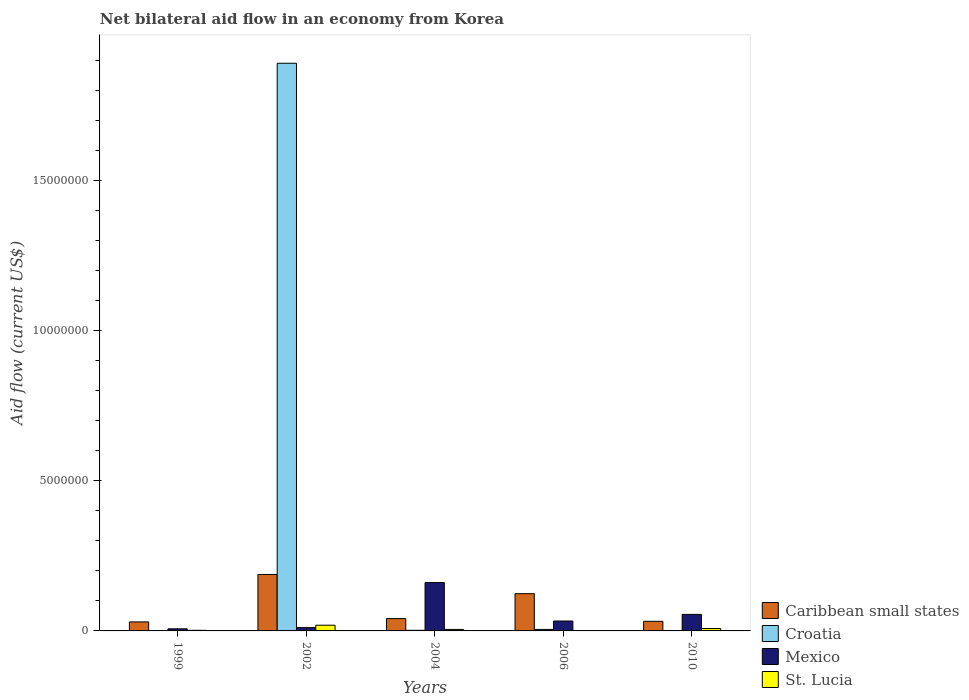How many groups of bars are there?
Provide a succinct answer. 5. How many bars are there on the 3rd tick from the left?
Offer a very short reply. 4. What is the net bilateral aid flow in St. Lucia in 2002?
Your answer should be very brief. 1.90e+05. Across all years, what is the minimum net bilateral aid flow in St. Lucia?
Ensure brevity in your answer.  10000. In which year was the net bilateral aid flow in Croatia maximum?
Keep it short and to the point. 2002. What is the total net bilateral aid flow in Caribbean small states in the graph?
Your response must be concise. 4.15e+06. What is the difference between the net bilateral aid flow in St. Lucia in 1999 and that in 2006?
Your answer should be very brief. 10000. What is the difference between the net bilateral aid flow in St. Lucia in 2010 and the net bilateral aid flow in Croatia in 2002?
Ensure brevity in your answer.  -1.88e+07. What is the average net bilateral aid flow in Mexico per year?
Provide a short and direct response. 5.34e+05. In the year 2004, what is the difference between the net bilateral aid flow in Caribbean small states and net bilateral aid flow in St. Lucia?
Offer a terse response. 3.60e+05. What is the ratio of the net bilateral aid flow in Mexico in 2004 to that in 2006?
Make the answer very short. 4.88. Is the difference between the net bilateral aid flow in Caribbean small states in 2002 and 2010 greater than the difference between the net bilateral aid flow in St. Lucia in 2002 and 2010?
Keep it short and to the point. Yes. What is the difference between the highest and the second highest net bilateral aid flow in Mexico?
Your answer should be compact. 1.06e+06. What is the difference between the highest and the lowest net bilateral aid flow in St. Lucia?
Provide a succinct answer. 1.80e+05. Is the sum of the net bilateral aid flow in Caribbean small states in 2004 and 2010 greater than the maximum net bilateral aid flow in St. Lucia across all years?
Your answer should be compact. Yes. Is it the case that in every year, the sum of the net bilateral aid flow in Caribbean small states and net bilateral aid flow in St. Lucia is greater than the sum of net bilateral aid flow in Croatia and net bilateral aid flow in Mexico?
Provide a short and direct response. Yes. Is it the case that in every year, the sum of the net bilateral aid flow in Croatia and net bilateral aid flow in Caribbean small states is greater than the net bilateral aid flow in St. Lucia?
Provide a short and direct response. Yes. How many bars are there?
Keep it short and to the point. 19. Are all the bars in the graph horizontal?
Offer a terse response. No. How many years are there in the graph?
Keep it short and to the point. 5. Does the graph contain any zero values?
Your answer should be very brief. Yes. Does the graph contain grids?
Ensure brevity in your answer.  No. Where does the legend appear in the graph?
Your answer should be very brief. Bottom right. How are the legend labels stacked?
Provide a succinct answer. Vertical. What is the title of the graph?
Provide a succinct answer. Net bilateral aid flow in an economy from Korea. Does "Mauritius" appear as one of the legend labels in the graph?
Your answer should be very brief. No. What is the label or title of the X-axis?
Keep it short and to the point. Years. What is the label or title of the Y-axis?
Offer a very short reply. Aid flow (current US$). What is the Aid flow (current US$) of Croatia in 1999?
Your answer should be compact. 10000. What is the Aid flow (current US$) of St. Lucia in 1999?
Offer a very short reply. 2.00e+04. What is the Aid flow (current US$) of Caribbean small states in 2002?
Keep it short and to the point. 1.88e+06. What is the Aid flow (current US$) of Croatia in 2002?
Offer a very short reply. 1.89e+07. What is the Aid flow (current US$) of Mexico in 2002?
Make the answer very short. 1.10e+05. What is the Aid flow (current US$) in Croatia in 2004?
Provide a short and direct response. 2.00e+04. What is the Aid flow (current US$) in Mexico in 2004?
Keep it short and to the point. 1.61e+06. What is the Aid flow (current US$) in Caribbean small states in 2006?
Give a very brief answer. 1.24e+06. What is the Aid flow (current US$) in Croatia in 2006?
Your answer should be compact. 5.00e+04. What is the Aid flow (current US$) of Mexico in 2006?
Make the answer very short. 3.30e+05. What is the Aid flow (current US$) in St. Lucia in 2006?
Offer a very short reply. 10000. What is the Aid flow (current US$) in Caribbean small states in 2010?
Make the answer very short. 3.20e+05. What is the Aid flow (current US$) in Mexico in 2010?
Offer a very short reply. 5.50e+05. What is the Aid flow (current US$) of St. Lucia in 2010?
Your answer should be very brief. 8.00e+04. Across all years, what is the maximum Aid flow (current US$) of Caribbean small states?
Your answer should be compact. 1.88e+06. Across all years, what is the maximum Aid flow (current US$) of Croatia?
Your response must be concise. 1.89e+07. Across all years, what is the maximum Aid flow (current US$) in Mexico?
Give a very brief answer. 1.61e+06. Across all years, what is the minimum Aid flow (current US$) in Croatia?
Offer a very short reply. 0. What is the total Aid flow (current US$) in Caribbean small states in the graph?
Provide a succinct answer. 4.15e+06. What is the total Aid flow (current US$) of Croatia in the graph?
Your response must be concise. 1.90e+07. What is the total Aid flow (current US$) of Mexico in the graph?
Provide a short and direct response. 2.67e+06. What is the difference between the Aid flow (current US$) in Caribbean small states in 1999 and that in 2002?
Your answer should be very brief. -1.58e+06. What is the difference between the Aid flow (current US$) of Croatia in 1999 and that in 2002?
Your response must be concise. -1.89e+07. What is the difference between the Aid flow (current US$) of St. Lucia in 1999 and that in 2002?
Give a very brief answer. -1.70e+05. What is the difference between the Aid flow (current US$) in Croatia in 1999 and that in 2004?
Provide a succinct answer. -10000. What is the difference between the Aid flow (current US$) of Mexico in 1999 and that in 2004?
Your answer should be compact. -1.54e+06. What is the difference between the Aid flow (current US$) of Caribbean small states in 1999 and that in 2006?
Offer a terse response. -9.40e+05. What is the difference between the Aid flow (current US$) in Mexico in 1999 and that in 2010?
Your answer should be very brief. -4.80e+05. What is the difference between the Aid flow (current US$) of St. Lucia in 1999 and that in 2010?
Keep it short and to the point. -6.00e+04. What is the difference between the Aid flow (current US$) in Caribbean small states in 2002 and that in 2004?
Your answer should be compact. 1.47e+06. What is the difference between the Aid flow (current US$) in Croatia in 2002 and that in 2004?
Offer a terse response. 1.89e+07. What is the difference between the Aid flow (current US$) in Mexico in 2002 and that in 2004?
Ensure brevity in your answer.  -1.50e+06. What is the difference between the Aid flow (current US$) of Caribbean small states in 2002 and that in 2006?
Your response must be concise. 6.40e+05. What is the difference between the Aid flow (current US$) of Croatia in 2002 and that in 2006?
Provide a short and direct response. 1.88e+07. What is the difference between the Aid flow (current US$) in Mexico in 2002 and that in 2006?
Keep it short and to the point. -2.20e+05. What is the difference between the Aid flow (current US$) in St. Lucia in 2002 and that in 2006?
Your answer should be compact. 1.80e+05. What is the difference between the Aid flow (current US$) of Caribbean small states in 2002 and that in 2010?
Offer a terse response. 1.56e+06. What is the difference between the Aid flow (current US$) of Mexico in 2002 and that in 2010?
Give a very brief answer. -4.40e+05. What is the difference between the Aid flow (current US$) in Caribbean small states in 2004 and that in 2006?
Offer a very short reply. -8.30e+05. What is the difference between the Aid flow (current US$) of Croatia in 2004 and that in 2006?
Your response must be concise. -3.00e+04. What is the difference between the Aid flow (current US$) in Mexico in 2004 and that in 2006?
Give a very brief answer. 1.28e+06. What is the difference between the Aid flow (current US$) of Caribbean small states in 2004 and that in 2010?
Ensure brevity in your answer.  9.00e+04. What is the difference between the Aid flow (current US$) of Mexico in 2004 and that in 2010?
Provide a short and direct response. 1.06e+06. What is the difference between the Aid flow (current US$) of St. Lucia in 2004 and that in 2010?
Offer a terse response. -3.00e+04. What is the difference between the Aid flow (current US$) of Caribbean small states in 2006 and that in 2010?
Your answer should be compact. 9.20e+05. What is the difference between the Aid flow (current US$) in St. Lucia in 2006 and that in 2010?
Give a very brief answer. -7.00e+04. What is the difference between the Aid flow (current US$) in Caribbean small states in 1999 and the Aid flow (current US$) in Croatia in 2002?
Offer a very short reply. -1.86e+07. What is the difference between the Aid flow (current US$) in Croatia in 1999 and the Aid flow (current US$) in Mexico in 2002?
Provide a short and direct response. -1.00e+05. What is the difference between the Aid flow (current US$) of Croatia in 1999 and the Aid flow (current US$) of St. Lucia in 2002?
Your response must be concise. -1.80e+05. What is the difference between the Aid flow (current US$) of Mexico in 1999 and the Aid flow (current US$) of St. Lucia in 2002?
Make the answer very short. -1.20e+05. What is the difference between the Aid flow (current US$) in Caribbean small states in 1999 and the Aid flow (current US$) in Mexico in 2004?
Your answer should be compact. -1.31e+06. What is the difference between the Aid flow (current US$) of Caribbean small states in 1999 and the Aid flow (current US$) of St. Lucia in 2004?
Provide a short and direct response. 2.50e+05. What is the difference between the Aid flow (current US$) in Croatia in 1999 and the Aid flow (current US$) in Mexico in 2004?
Offer a terse response. -1.60e+06. What is the difference between the Aid flow (current US$) of Croatia in 1999 and the Aid flow (current US$) of St. Lucia in 2004?
Provide a succinct answer. -4.00e+04. What is the difference between the Aid flow (current US$) of Mexico in 1999 and the Aid flow (current US$) of St. Lucia in 2004?
Offer a very short reply. 2.00e+04. What is the difference between the Aid flow (current US$) of Caribbean small states in 1999 and the Aid flow (current US$) of St. Lucia in 2006?
Provide a succinct answer. 2.90e+05. What is the difference between the Aid flow (current US$) of Croatia in 1999 and the Aid flow (current US$) of Mexico in 2006?
Your response must be concise. -3.20e+05. What is the difference between the Aid flow (current US$) in Croatia in 1999 and the Aid flow (current US$) in St. Lucia in 2006?
Provide a succinct answer. 0. What is the difference between the Aid flow (current US$) in Caribbean small states in 1999 and the Aid flow (current US$) in Mexico in 2010?
Your answer should be very brief. -2.50e+05. What is the difference between the Aid flow (current US$) of Caribbean small states in 1999 and the Aid flow (current US$) of St. Lucia in 2010?
Ensure brevity in your answer.  2.20e+05. What is the difference between the Aid flow (current US$) in Croatia in 1999 and the Aid flow (current US$) in Mexico in 2010?
Your response must be concise. -5.40e+05. What is the difference between the Aid flow (current US$) in Mexico in 1999 and the Aid flow (current US$) in St. Lucia in 2010?
Provide a succinct answer. -10000. What is the difference between the Aid flow (current US$) of Caribbean small states in 2002 and the Aid flow (current US$) of Croatia in 2004?
Ensure brevity in your answer.  1.86e+06. What is the difference between the Aid flow (current US$) of Caribbean small states in 2002 and the Aid flow (current US$) of Mexico in 2004?
Keep it short and to the point. 2.70e+05. What is the difference between the Aid flow (current US$) of Caribbean small states in 2002 and the Aid flow (current US$) of St. Lucia in 2004?
Give a very brief answer. 1.83e+06. What is the difference between the Aid flow (current US$) in Croatia in 2002 and the Aid flow (current US$) in Mexico in 2004?
Your answer should be compact. 1.73e+07. What is the difference between the Aid flow (current US$) in Croatia in 2002 and the Aid flow (current US$) in St. Lucia in 2004?
Offer a terse response. 1.88e+07. What is the difference between the Aid flow (current US$) of Caribbean small states in 2002 and the Aid flow (current US$) of Croatia in 2006?
Offer a terse response. 1.83e+06. What is the difference between the Aid flow (current US$) of Caribbean small states in 2002 and the Aid flow (current US$) of Mexico in 2006?
Give a very brief answer. 1.55e+06. What is the difference between the Aid flow (current US$) in Caribbean small states in 2002 and the Aid flow (current US$) in St. Lucia in 2006?
Your response must be concise. 1.87e+06. What is the difference between the Aid flow (current US$) in Croatia in 2002 and the Aid flow (current US$) in Mexico in 2006?
Your response must be concise. 1.86e+07. What is the difference between the Aid flow (current US$) in Croatia in 2002 and the Aid flow (current US$) in St. Lucia in 2006?
Provide a short and direct response. 1.89e+07. What is the difference between the Aid flow (current US$) of Mexico in 2002 and the Aid flow (current US$) of St. Lucia in 2006?
Provide a short and direct response. 1.00e+05. What is the difference between the Aid flow (current US$) in Caribbean small states in 2002 and the Aid flow (current US$) in Mexico in 2010?
Your answer should be very brief. 1.33e+06. What is the difference between the Aid flow (current US$) in Caribbean small states in 2002 and the Aid flow (current US$) in St. Lucia in 2010?
Keep it short and to the point. 1.80e+06. What is the difference between the Aid flow (current US$) in Croatia in 2002 and the Aid flow (current US$) in Mexico in 2010?
Keep it short and to the point. 1.84e+07. What is the difference between the Aid flow (current US$) of Croatia in 2002 and the Aid flow (current US$) of St. Lucia in 2010?
Make the answer very short. 1.88e+07. What is the difference between the Aid flow (current US$) of Mexico in 2002 and the Aid flow (current US$) of St. Lucia in 2010?
Provide a succinct answer. 3.00e+04. What is the difference between the Aid flow (current US$) of Croatia in 2004 and the Aid flow (current US$) of Mexico in 2006?
Offer a terse response. -3.10e+05. What is the difference between the Aid flow (current US$) of Croatia in 2004 and the Aid flow (current US$) of St. Lucia in 2006?
Your response must be concise. 10000. What is the difference between the Aid flow (current US$) of Mexico in 2004 and the Aid flow (current US$) of St. Lucia in 2006?
Make the answer very short. 1.60e+06. What is the difference between the Aid flow (current US$) in Caribbean small states in 2004 and the Aid flow (current US$) in Mexico in 2010?
Provide a short and direct response. -1.40e+05. What is the difference between the Aid flow (current US$) of Croatia in 2004 and the Aid flow (current US$) of Mexico in 2010?
Offer a very short reply. -5.30e+05. What is the difference between the Aid flow (current US$) in Croatia in 2004 and the Aid flow (current US$) in St. Lucia in 2010?
Offer a terse response. -6.00e+04. What is the difference between the Aid flow (current US$) of Mexico in 2004 and the Aid flow (current US$) of St. Lucia in 2010?
Keep it short and to the point. 1.53e+06. What is the difference between the Aid flow (current US$) in Caribbean small states in 2006 and the Aid flow (current US$) in Mexico in 2010?
Provide a succinct answer. 6.90e+05. What is the difference between the Aid flow (current US$) in Caribbean small states in 2006 and the Aid flow (current US$) in St. Lucia in 2010?
Offer a terse response. 1.16e+06. What is the difference between the Aid flow (current US$) in Croatia in 2006 and the Aid flow (current US$) in Mexico in 2010?
Your response must be concise. -5.00e+05. What is the difference between the Aid flow (current US$) of Croatia in 2006 and the Aid flow (current US$) of St. Lucia in 2010?
Your answer should be very brief. -3.00e+04. What is the difference between the Aid flow (current US$) of Mexico in 2006 and the Aid flow (current US$) of St. Lucia in 2010?
Make the answer very short. 2.50e+05. What is the average Aid flow (current US$) in Caribbean small states per year?
Your answer should be compact. 8.30e+05. What is the average Aid flow (current US$) of Croatia per year?
Make the answer very short. 3.80e+06. What is the average Aid flow (current US$) of Mexico per year?
Provide a short and direct response. 5.34e+05. In the year 1999, what is the difference between the Aid flow (current US$) in Caribbean small states and Aid flow (current US$) in Croatia?
Ensure brevity in your answer.  2.90e+05. In the year 1999, what is the difference between the Aid flow (current US$) in Caribbean small states and Aid flow (current US$) in Mexico?
Your response must be concise. 2.30e+05. In the year 1999, what is the difference between the Aid flow (current US$) in Croatia and Aid flow (current US$) in Mexico?
Give a very brief answer. -6.00e+04. In the year 1999, what is the difference between the Aid flow (current US$) in Croatia and Aid flow (current US$) in St. Lucia?
Ensure brevity in your answer.  -10000. In the year 1999, what is the difference between the Aid flow (current US$) of Mexico and Aid flow (current US$) of St. Lucia?
Your response must be concise. 5.00e+04. In the year 2002, what is the difference between the Aid flow (current US$) in Caribbean small states and Aid flow (current US$) in Croatia?
Ensure brevity in your answer.  -1.70e+07. In the year 2002, what is the difference between the Aid flow (current US$) in Caribbean small states and Aid flow (current US$) in Mexico?
Give a very brief answer. 1.77e+06. In the year 2002, what is the difference between the Aid flow (current US$) in Caribbean small states and Aid flow (current US$) in St. Lucia?
Your answer should be very brief. 1.69e+06. In the year 2002, what is the difference between the Aid flow (current US$) in Croatia and Aid flow (current US$) in Mexico?
Your response must be concise. 1.88e+07. In the year 2002, what is the difference between the Aid flow (current US$) in Croatia and Aid flow (current US$) in St. Lucia?
Your answer should be very brief. 1.87e+07. In the year 2002, what is the difference between the Aid flow (current US$) of Mexico and Aid flow (current US$) of St. Lucia?
Offer a very short reply. -8.00e+04. In the year 2004, what is the difference between the Aid flow (current US$) in Caribbean small states and Aid flow (current US$) in Mexico?
Make the answer very short. -1.20e+06. In the year 2004, what is the difference between the Aid flow (current US$) of Croatia and Aid flow (current US$) of Mexico?
Your answer should be very brief. -1.59e+06. In the year 2004, what is the difference between the Aid flow (current US$) of Mexico and Aid flow (current US$) of St. Lucia?
Offer a terse response. 1.56e+06. In the year 2006, what is the difference between the Aid flow (current US$) in Caribbean small states and Aid flow (current US$) in Croatia?
Make the answer very short. 1.19e+06. In the year 2006, what is the difference between the Aid flow (current US$) of Caribbean small states and Aid flow (current US$) of Mexico?
Provide a short and direct response. 9.10e+05. In the year 2006, what is the difference between the Aid flow (current US$) of Caribbean small states and Aid flow (current US$) of St. Lucia?
Keep it short and to the point. 1.23e+06. In the year 2006, what is the difference between the Aid flow (current US$) in Croatia and Aid flow (current US$) in Mexico?
Offer a terse response. -2.80e+05. In the year 2010, what is the difference between the Aid flow (current US$) of Caribbean small states and Aid flow (current US$) of Mexico?
Your answer should be very brief. -2.30e+05. In the year 2010, what is the difference between the Aid flow (current US$) of Caribbean small states and Aid flow (current US$) of St. Lucia?
Ensure brevity in your answer.  2.40e+05. In the year 2010, what is the difference between the Aid flow (current US$) in Mexico and Aid flow (current US$) in St. Lucia?
Your response must be concise. 4.70e+05. What is the ratio of the Aid flow (current US$) of Caribbean small states in 1999 to that in 2002?
Offer a very short reply. 0.16. What is the ratio of the Aid flow (current US$) of Mexico in 1999 to that in 2002?
Keep it short and to the point. 0.64. What is the ratio of the Aid flow (current US$) of St. Lucia in 1999 to that in 2002?
Offer a very short reply. 0.11. What is the ratio of the Aid flow (current US$) of Caribbean small states in 1999 to that in 2004?
Offer a very short reply. 0.73. What is the ratio of the Aid flow (current US$) in Mexico in 1999 to that in 2004?
Provide a short and direct response. 0.04. What is the ratio of the Aid flow (current US$) of St. Lucia in 1999 to that in 2004?
Ensure brevity in your answer.  0.4. What is the ratio of the Aid flow (current US$) of Caribbean small states in 1999 to that in 2006?
Provide a short and direct response. 0.24. What is the ratio of the Aid flow (current US$) of Croatia in 1999 to that in 2006?
Keep it short and to the point. 0.2. What is the ratio of the Aid flow (current US$) of Mexico in 1999 to that in 2006?
Give a very brief answer. 0.21. What is the ratio of the Aid flow (current US$) of Caribbean small states in 1999 to that in 2010?
Ensure brevity in your answer.  0.94. What is the ratio of the Aid flow (current US$) of Mexico in 1999 to that in 2010?
Keep it short and to the point. 0.13. What is the ratio of the Aid flow (current US$) in Caribbean small states in 2002 to that in 2004?
Provide a short and direct response. 4.59. What is the ratio of the Aid flow (current US$) in Croatia in 2002 to that in 2004?
Make the answer very short. 945. What is the ratio of the Aid flow (current US$) of Mexico in 2002 to that in 2004?
Provide a succinct answer. 0.07. What is the ratio of the Aid flow (current US$) of St. Lucia in 2002 to that in 2004?
Give a very brief answer. 3.8. What is the ratio of the Aid flow (current US$) of Caribbean small states in 2002 to that in 2006?
Make the answer very short. 1.52. What is the ratio of the Aid flow (current US$) in Croatia in 2002 to that in 2006?
Make the answer very short. 378. What is the ratio of the Aid flow (current US$) in St. Lucia in 2002 to that in 2006?
Offer a terse response. 19. What is the ratio of the Aid flow (current US$) in Caribbean small states in 2002 to that in 2010?
Ensure brevity in your answer.  5.88. What is the ratio of the Aid flow (current US$) in St. Lucia in 2002 to that in 2010?
Keep it short and to the point. 2.38. What is the ratio of the Aid flow (current US$) of Caribbean small states in 2004 to that in 2006?
Your answer should be very brief. 0.33. What is the ratio of the Aid flow (current US$) of Mexico in 2004 to that in 2006?
Ensure brevity in your answer.  4.88. What is the ratio of the Aid flow (current US$) of St. Lucia in 2004 to that in 2006?
Your answer should be very brief. 5. What is the ratio of the Aid flow (current US$) of Caribbean small states in 2004 to that in 2010?
Offer a very short reply. 1.28. What is the ratio of the Aid flow (current US$) of Mexico in 2004 to that in 2010?
Ensure brevity in your answer.  2.93. What is the ratio of the Aid flow (current US$) in Caribbean small states in 2006 to that in 2010?
Make the answer very short. 3.88. What is the ratio of the Aid flow (current US$) in Mexico in 2006 to that in 2010?
Make the answer very short. 0.6. What is the difference between the highest and the second highest Aid flow (current US$) of Caribbean small states?
Provide a succinct answer. 6.40e+05. What is the difference between the highest and the second highest Aid flow (current US$) in Croatia?
Provide a succinct answer. 1.88e+07. What is the difference between the highest and the second highest Aid flow (current US$) of Mexico?
Give a very brief answer. 1.06e+06. What is the difference between the highest and the lowest Aid flow (current US$) in Caribbean small states?
Ensure brevity in your answer.  1.58e+06. What is the difference between the highest and the lowest Aid flow (current US$) in Croatia?
Offer a very short reply. 1.89e+07. What is the difference between the highest and the lowest Aid flow (current US$) of Mexico?
Your answer should be compact. 1.54e+06. What is the difference between the highest and the lowest Aid flow (current US$) in St. Lucia?
Make the answer very short. 1.80e+05. 